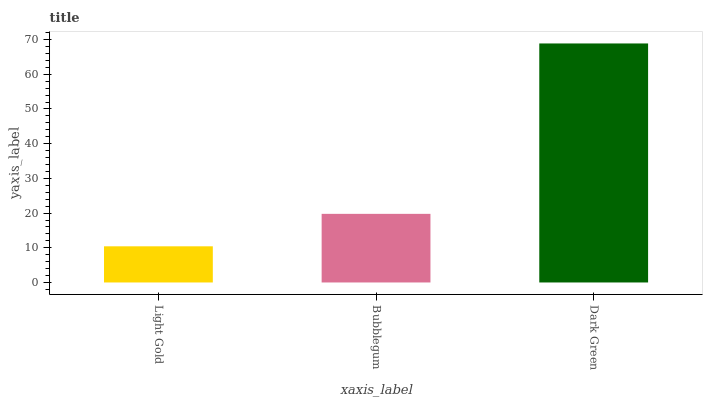Is Light Gold the minimum?
Answer yes or no. Yes. Is Dark Green the maximum?
Answer yes or no. Yes. Is Bubblegum the minimum?
Answer yes or no. No. Is Bubblegum the maximum?
Answer yes or no. No. Is Bubblegum greater than Light Gold?
Answer yes or no. Yes. Is Light Gold less than Bubblegum?
Answer yes or no. Yes. Is Light Gold greater than Bubblegum?
Answer yes or no. No. Is Bubblegum less than Light Gold?
Answer yes or no. No. Is Bubblegum the high median?
Answer yes or no. Yes. Is Bubblegum the low median?
Answer yes or no. Yes. Is Dark Green the high median?
Answer yes or no. No. Is Dark Green the low median?
Answer yes or no. No. 